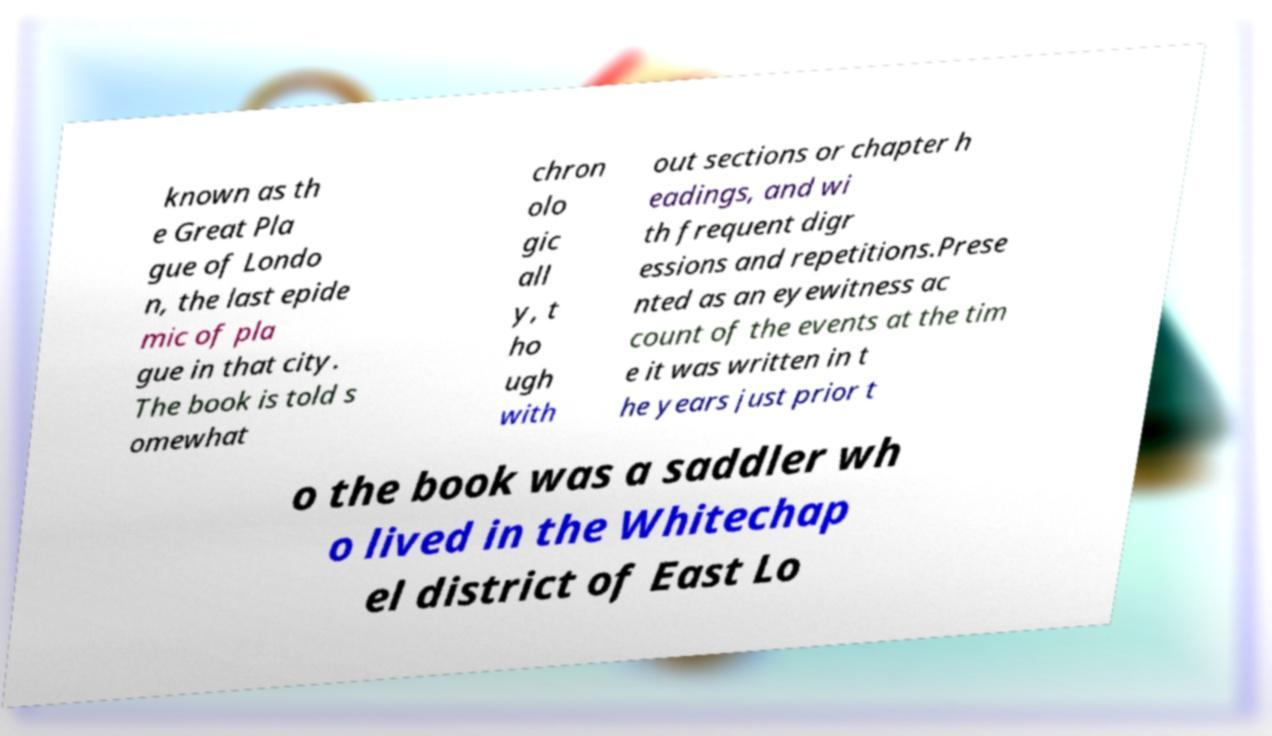Can you accurately transcribe the text from the provided image for me? known as th e Great Pla gue of Londo n, the last epide mic of pla gue in that city. The book is told s omewhat chron olo gic all y, t ho ugh with out sections or chapter h eadings, and wi th frequent digr essions and repetitions.Prese nted as an eyewitness ac count of the events at the tim e it was written in t he years just prior t o the book was a saddler wh o lived in the Whitechap el district of East Lo 